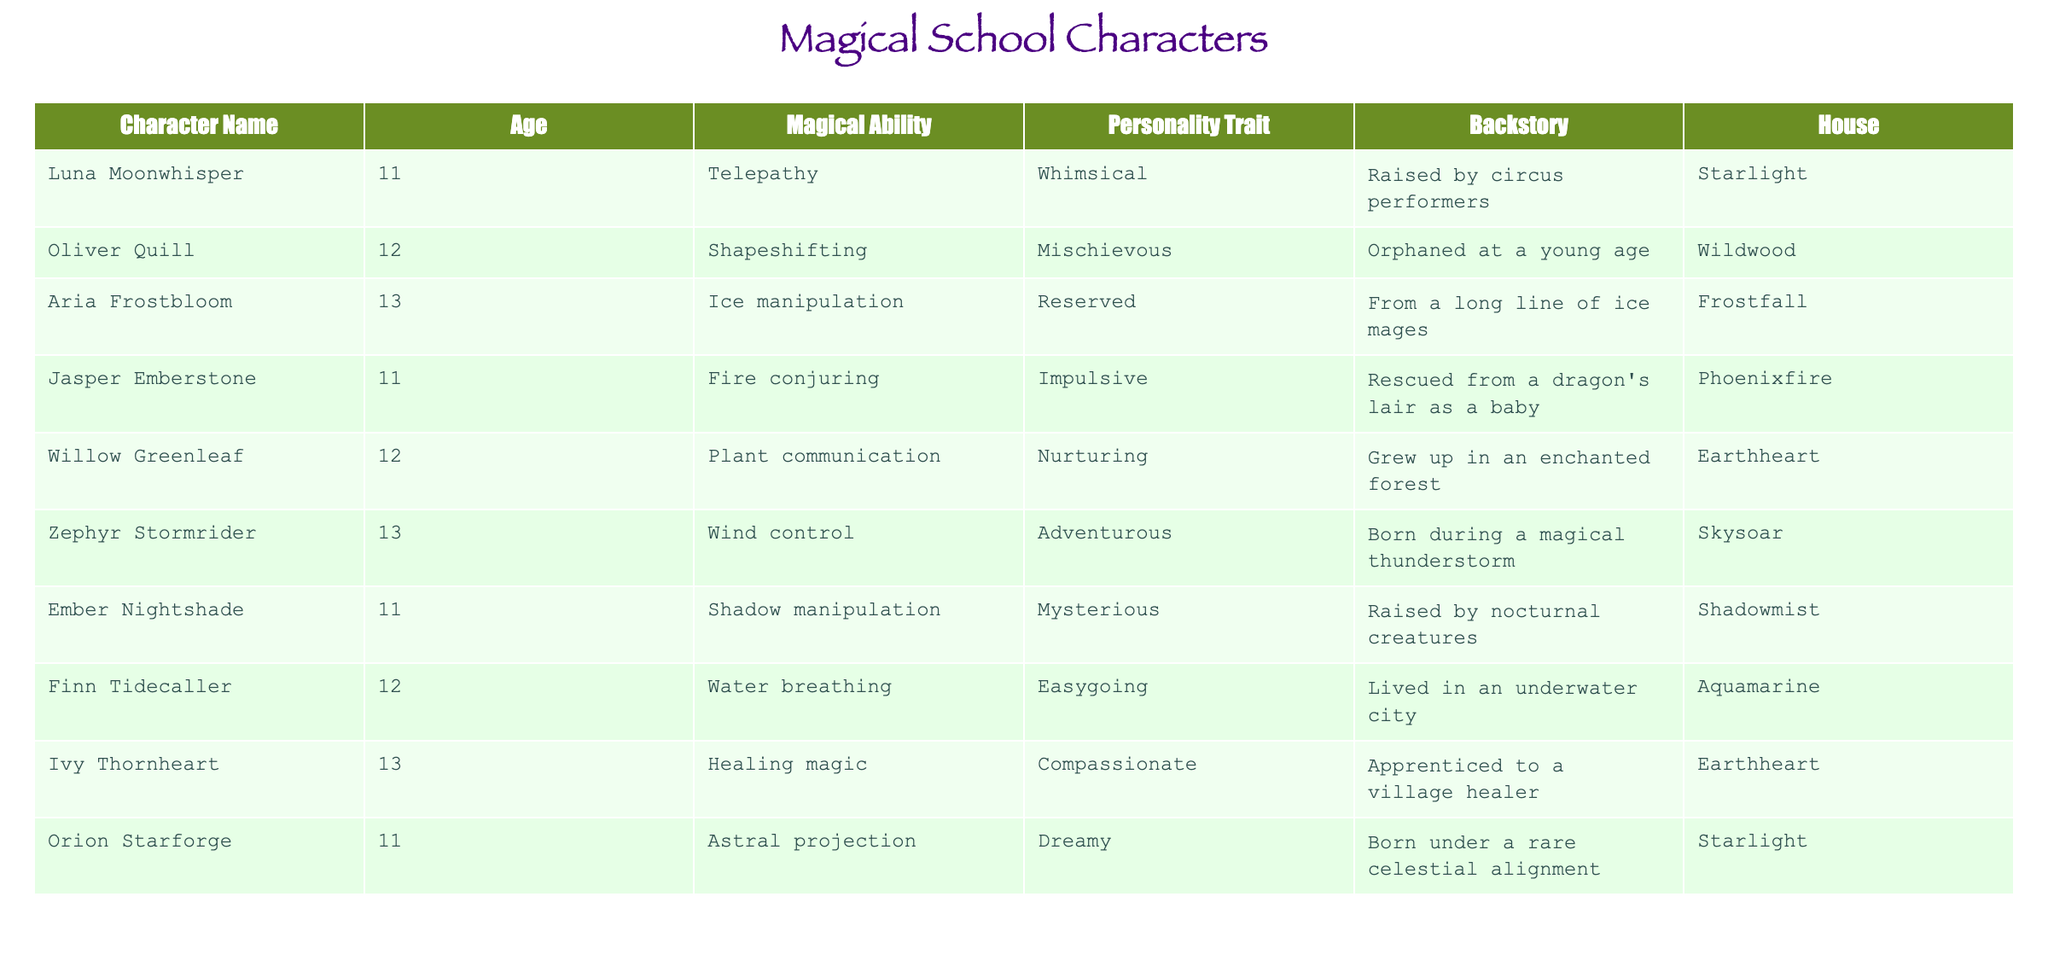What is the magical ability of Luna Moonwhisper? By looking at the row corresponding to Luna Moonwhisper in the table, we can see that her magical ability is listed as Telepathy.
Answer: Telepathy How many characters have the personality trait "Adventurous"? Reviewing the table, we find that Zephyr Stormrider is the only character with the personality trait "Adventurous". Thus, there is a total of one character.
Answer: 1 Which character is associated with the house "Earthheart"? In the table, we identify two characters associated with the house "Earthheart": Willow Greenleaf and Ivy Thornheart.
Answer: Willow Greenleaf and Ivy Thornheart How many characters are older than 11? The ages of the characters are: Luna Moonwhisper (11), Oliver Quill (12), Aria Frostbloom (13), Jasper Emberstone (11), Willow Greenleaf (12), Zephyr Stormrider (13), Ember Nightshade (11), Finn Tidecaller (12), and Ivy Thornheart (13). Counting those older than 11 gives us five characters: Oliver Quill, Aria Frostbloom, Willow Greenleaf, Zephyr Stormrider, Finn Tidecaller, and Ivy Thornheart.
Answer: 5 Which magical abilities are unique to a single character? By analyzing the table, we see that "Telepathy," "Mischievous," "Ice manipulation," "Healing magic," and "Water breathing" appear only once across the characters. Hence, these magical abilities belong uniquely to one character each.
Answer: Telepathy, Healing magic Does any character have both the personality trait "Reserved" and is from the house "Frostfall"? The only character listed in the "Frostfall" house is Aria Frostbloom, who has the personality trait "Reserved". Therefore, the answer is yes.
Answer: Yes Which character was raised by nocturnal creatures? Referring to the table for Ember Nightshade, we can confirm that this character was raised by nocturnal creatures based on the provided backstory.
Answer: Ember Nightshade How many characters can manipulate elements (fire, ice, water, and plant)? Going through the table, we find Jasper Emberstone (Fire conjuring), Aria Frostbloom (Ice manipulation), Finn Tidecaller (Water breathing), and Willow Greenleaf (Plant communication). That's a total of four characters who can manipulate these elements.
Answer: 4 Is there a character who has been orphaned? Yes, Oliver Quill is explicitly stated to have been orphaned at a young age according to the backstory given in the table.
Answer: Yes 